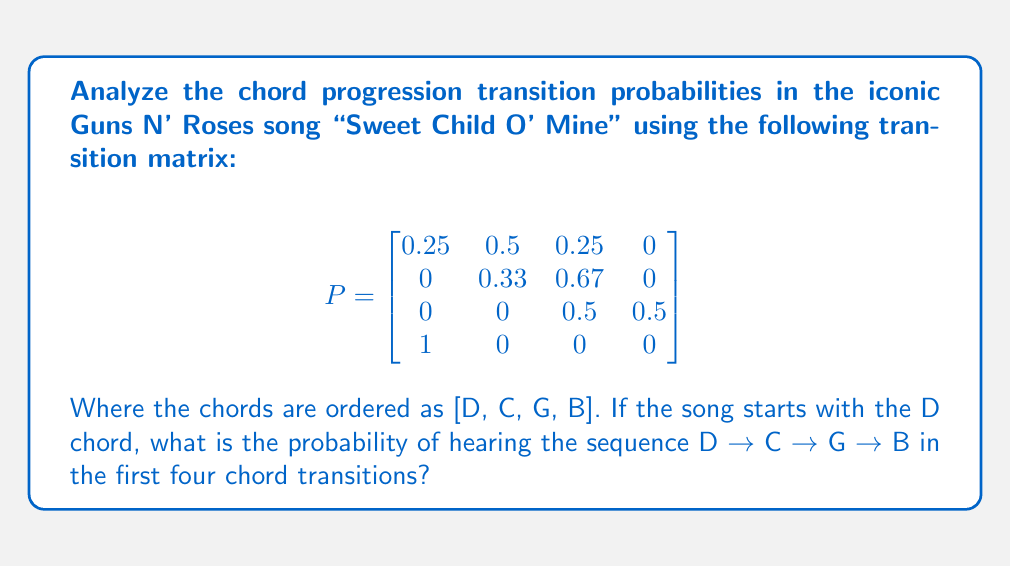Show me your answer to this math problem. Let's approach this step-by-step:

1) We need to find the probability of the sequence D → C → G → B.

2) This can be calculated by multiplying the individual transition probabilities:

   P(D → C) × P(C → G) × P(G → B)

3) From the transition matrix:
   - P(D → C) = 0.5 (2nd column, 1st row)
   - P(C → G) = 0.67 (3rd column, 2nd row)
   - P(G → B) = 0.5 (4th column, 3rd row)

4) Multiplying these probabilities:

   $$ 0.5 \times 0.67 \times 0.5 = 0.1675 $$

5) Therefore, the probability of hearing the sequence D → C → G → B in the first four chord transitions, given that the song starts with D, is 0.1675 or 16.75%.
Answer: 0.1675 